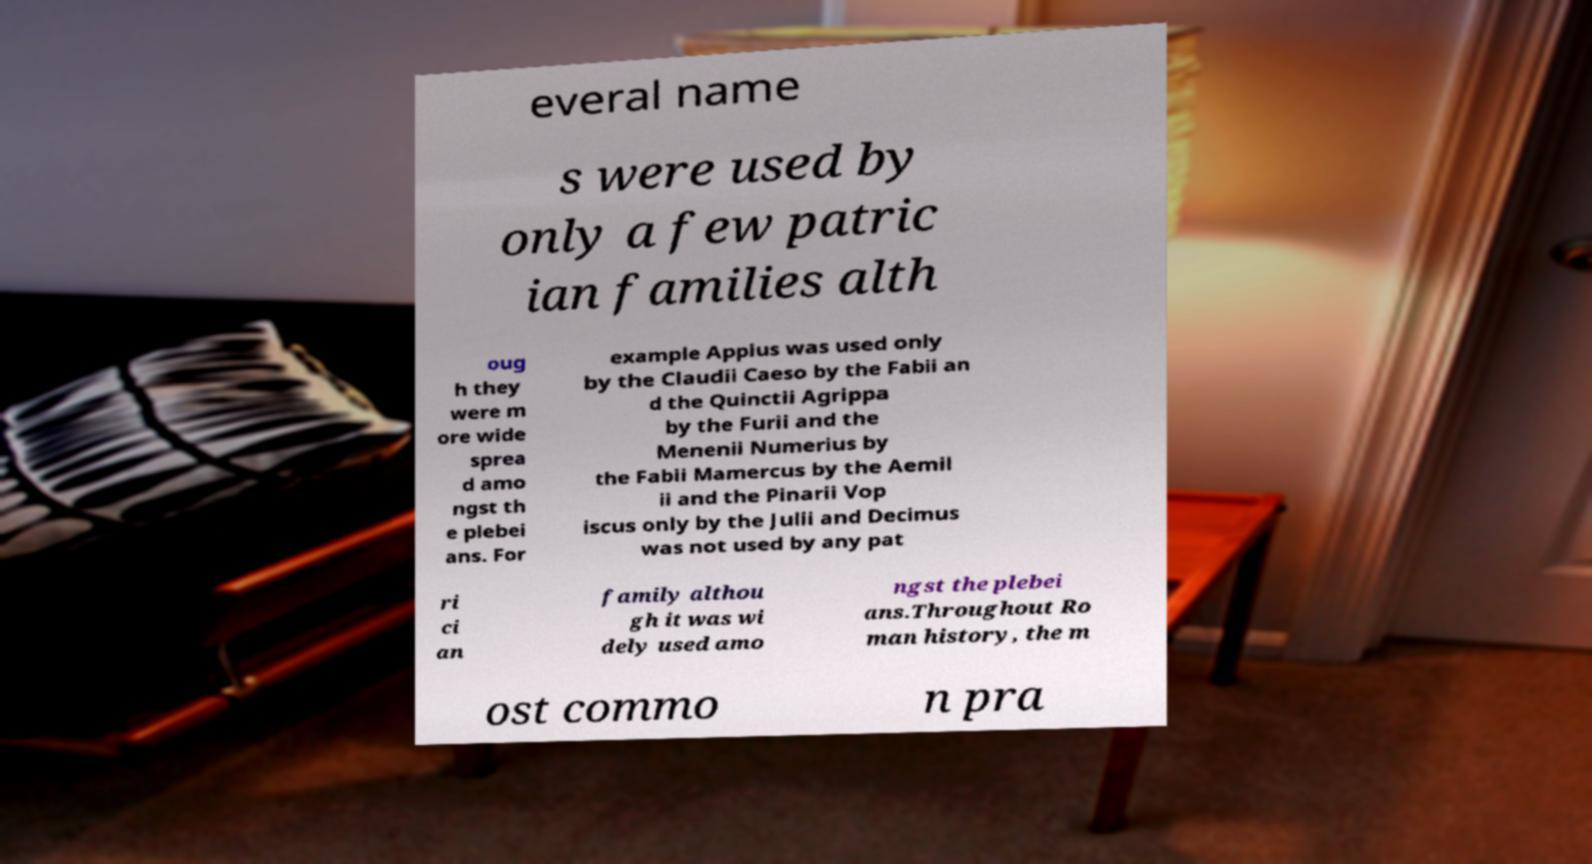For documentation purposes, I need the text within this image transcribed. Could you provide that? everal name s were used by only a few patric ian families alth oug h they were m ore wide sprea d amo ngst th e plebei ans. For example Appius was used only by the Claudii Caeso by the Fabii an d the Quinctii Agrippa by the Furii and the Menenii Numerius by the Fabii Mamercus by the Aemil ii and the Pinarii Vop iscus only by the Julii and Decimus was not used by any pat ri ci an family althou gh it was wi dely used amo ngst the plebei ans.Throughout Ro man history, the m ost commo n pra 